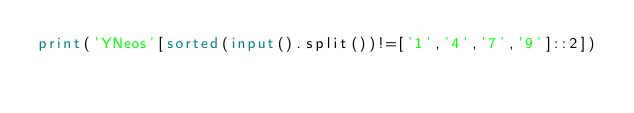<code> <loc_0><loc_0><loc_500><loc_500><_Python_>print('YNeos'[sorted(input().split())!=['1','4','7','9']::2])</code> 